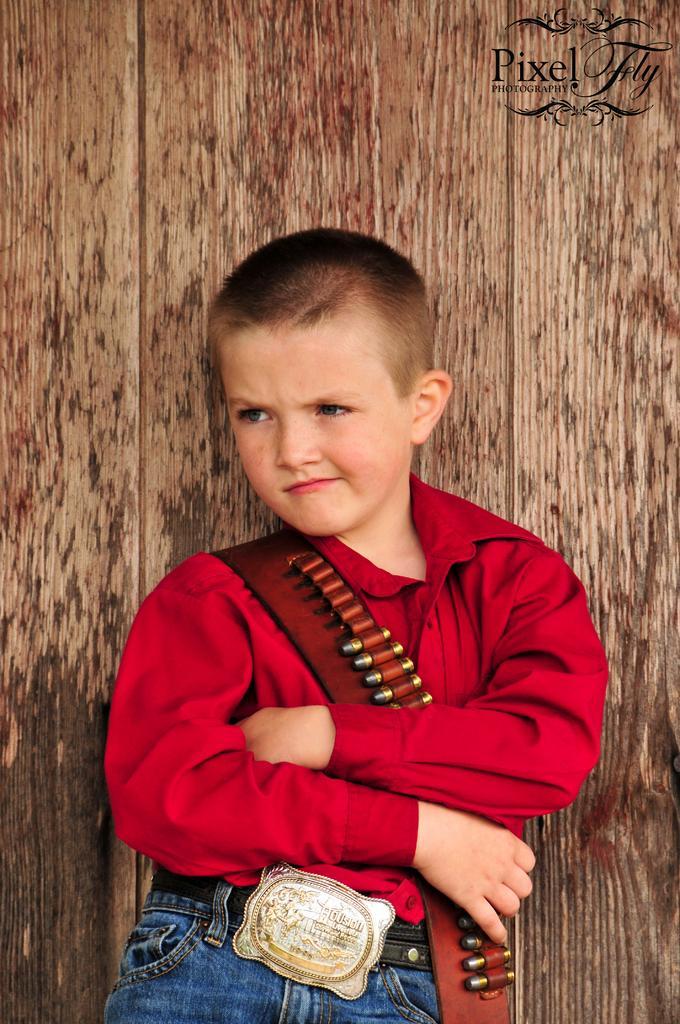Can you describe this image briefly? In the center of the image there is a boy standing. In the background there is a wall. 